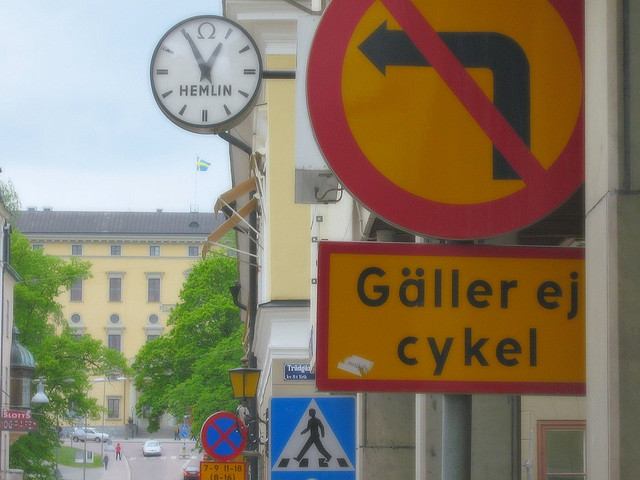Identify the text contained in this image. HEM e GALLER cykel Tridge 5LOTTS 